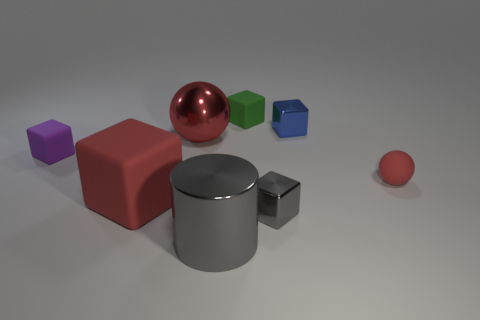Is the number of gray cylinders that are behind the large red matte object less than the number of green cubes?
Your response must be concise. Yes. Are there any purple cubes to the right of the gray cylinder?
Give a very brief answer. No. Is there a blue metallic object that has the same shape as the green matte object?
Offer a very short reply. Yes. The green rubber thing that is the same size as the gray metallic cube is what shape?
Keep it short and to the point. Cube. What number of things are either red things on the right side of the green cube or small cubes?
Provide a short and direct response. 5. Does the big cylinder have the same color as the large ball?
Your response must be concise. No. What is the size of the red ball that is in front of the red metallic ball?
Make the answer very short. Small. Is there a metallic ball that has the same size as the gray cylinder?
Offer a very short reply. Yes. Does the rubber block behind the blue block have the same size as the large block?
Give a very brief answer. No. How big is the red block?
Offer a terse response. Large. 